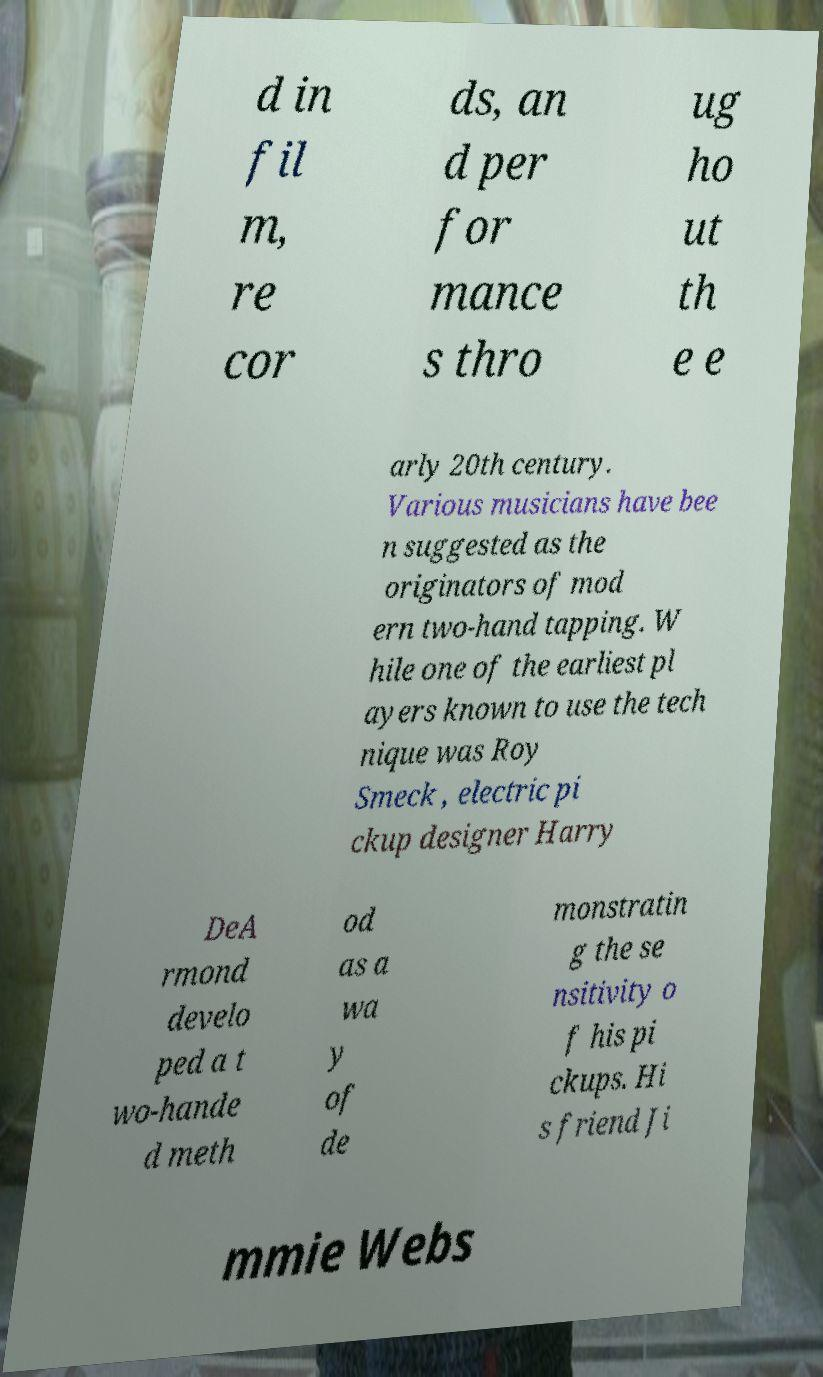There's text embedded in this image that I need extracted. Can you transcribe it verbatim? d in fil m, re cor ds, an d per for mance s thro ug ho ut th e e arly 20th century. Various musicians have bee n suggested as the originators of mod ern two-hand tapping. W hile one of the earliest pl ayers known to use the tech nique was Roy Smeck , electric pi ckup designer Harry DeA rmond develo ped a t wo-hande d meth od as a wa y of de monstratin g the se nsitivity o f his pi ckups. Hi s friend Ji mmie Webs 